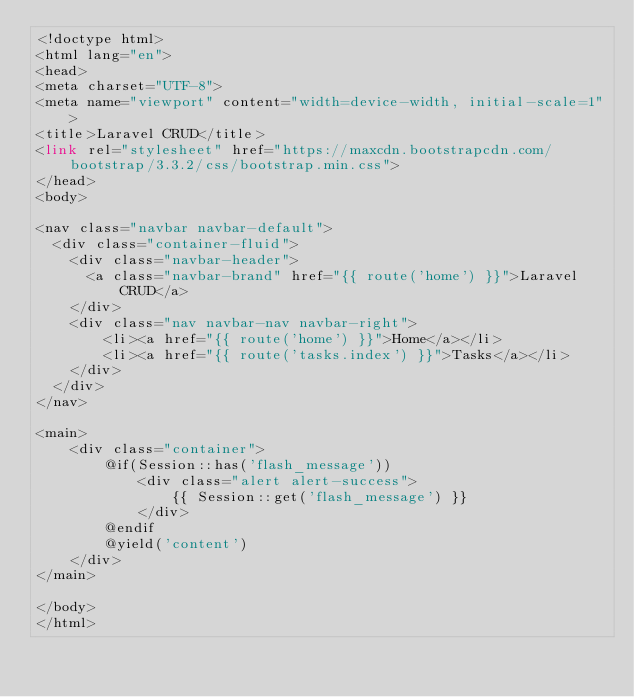Convert code to text. <code><loc_0><loc_0><loc_500><loc_500><_PHP_><!doctype html>
<html lang="en">
<head>
<meta charset="UTF-8">
<meta name="viewport" content="width=device-width, initial-scale=1">
<title>Laravel CRUD</title>
<link rel="stylesheet" href="https://maxcdn.bootstrapcdn.com/bootstrap/3.3.2/css/bootstrap.min.css">
</head>
<body>

<nav class="navbar navbar-default">
  <div class="container-fluid">
    <div class="navbar-header">
      <a class="navbar-brand" href="{{ route('home') }}">Laravel CRUD</a>
    </div>
    <div class="nav navbar-nav navbar-right">
        <li><a href="{{ route('home') }}">Home</a></li>
        <li><a href="{{ route('tasks.index') }}">Tasks</a></li>
    </div>
  </div>
</nav>

<main>
    <div class="container">
        @if(Session::has('flash_message'))
            <div class="alert alert-success">
                {{ Session::get('flash_message') }}
            </div>
        @endif
        @yield('content')
    </div>
</main>

</body>
</html></code> 